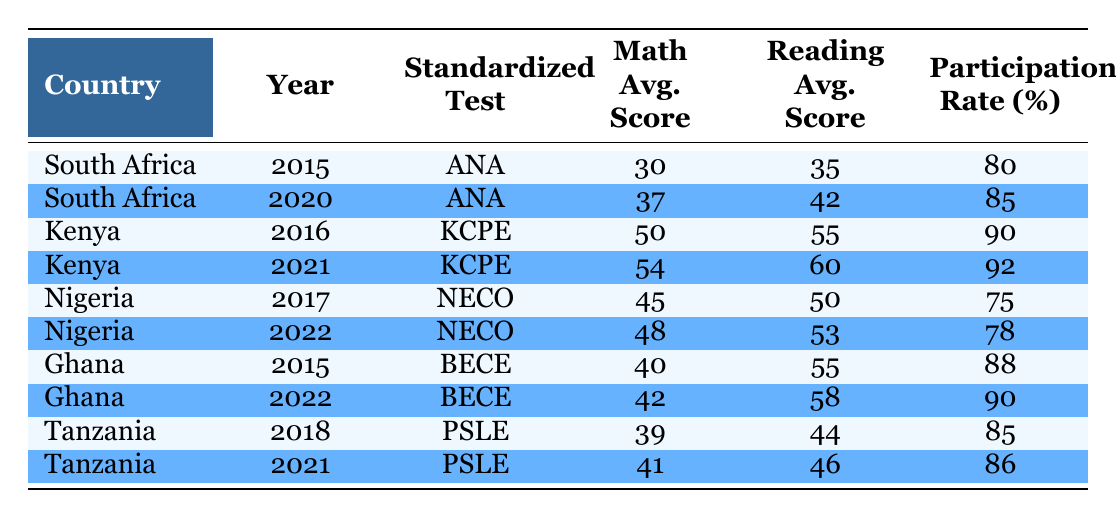What is the participation rate in Kenya for the KCPE in 2021? The table indicates the participation rate for Kenya in 2021 under the "KCPE" standardized test, which is shown in the corresponding row. Referring to that row, the participation rate is 92%.
Answer: 92% What was the average math score for South Africa in 2015? By looking at the row for South Africa in 2015, the average math score is listed directly in the table. It clearly states that the math average score is 30.
Answer: 30 Did Ghana have a higher reading average score in 2022 compared to 2015? The reading average scores for Ghana in 2015 and 2022 can be compared by looking at the respective rows. In 2015, the reading average score was 55, and in 2022, it was 58. Since 58 is greater than 55, the answer is yes.
Answer: Yes What is the difference in math average scores for Tanzania between 2018 and 2021? To find the difference, we need to subtract the math average score for Tanzania in 2018 from that in 2021. From the table, the 2018 score is 39, and the 2021 score is 41. Calculating the difference gives us 41 - 39 = 2.
Answer: 2 Which country had the highest math average score in the table? The table includes various countries and their math average scores, which can be compared. The highest score among the provided data is 54, which is from Kenya in 2021.
Answer: Kenya What was the average reading score for Nigeria across the years it is represented? To calculate the average reading score for Nigeria, we must find all its reading scores from the table, which are 50 (2017) and 53 (2022). The average is (50 + 53) / 2 = 103 / 2 = 51.5.
Answer: 51.5 Was the participation rate in Nigeria higher in 2017 than in 2022? Looking at the rows for Nigeria in both years, the participation rate in 2017 is 75%, and in 2022 it is 78%. Comparing these figures shows that 75% is not higher than 78%, so the answer is no.
Answer: No What is the total participation rate from all the countries listed in the table for the year 2022? The countries with data for 2022 are Nigeria (78%), Ghana (90%), and the participation rate for Tanzania is not available for 2022. Summing the participation rates: 78 + 90 = 168. Since only two countries have data, we take the average, which is 168 / 2 = 84.
Answer: 84 What was the reading average score in South Africa for the ANA in 2020 compared to the same metric in 2015? The reading average scores for South Africa in 2015 and 2020 can be directly compared from the table. In 2015, the score was 35, and in 2020 it was 42. Since 42 is greater than 35, the answer is yes.
Answer: Yes 